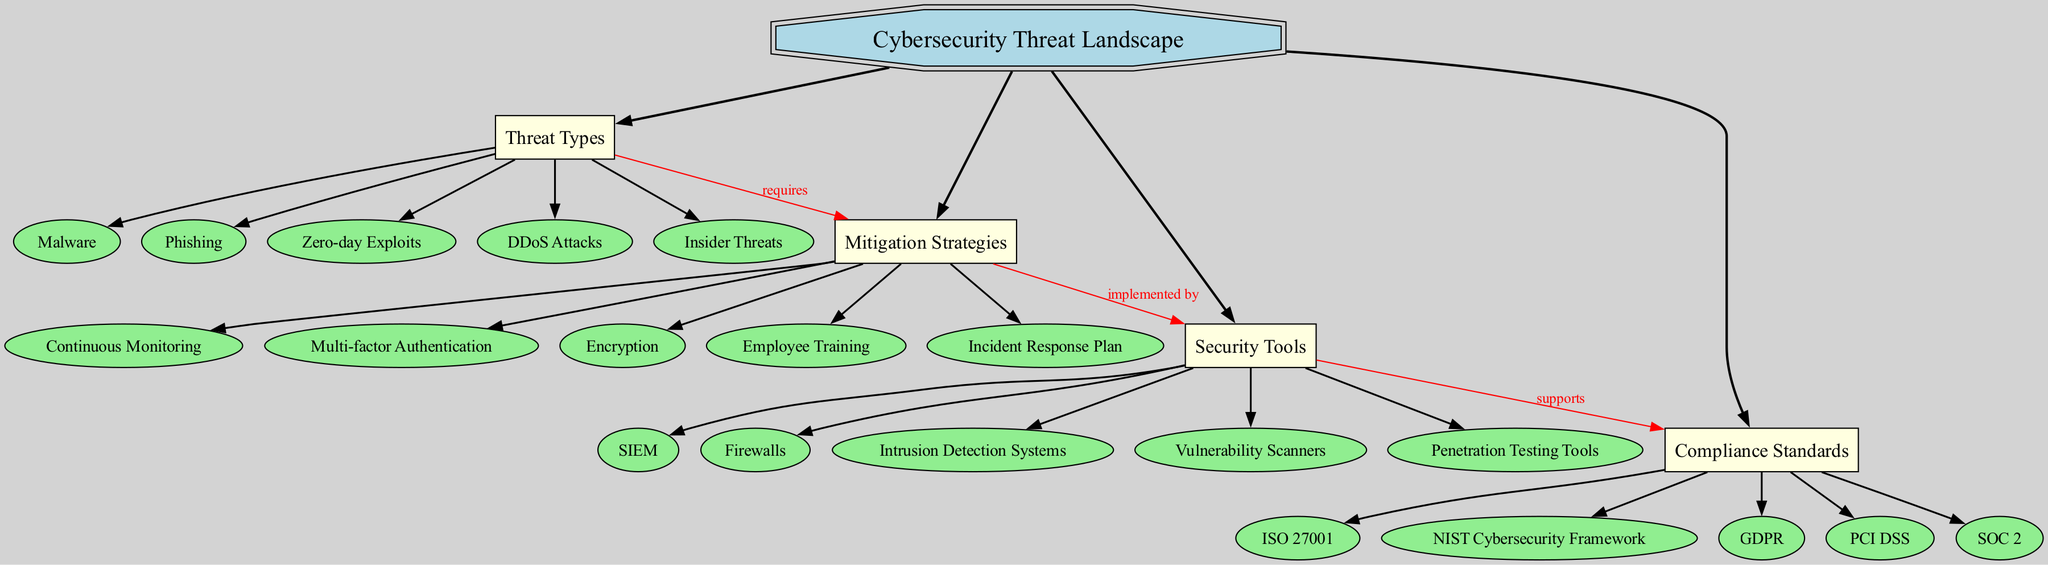What are the subnodes under Threat Types? The subnodes under "Threat Types" are listed directly connected to it in the diagram, which includes Malware, Phishing, Zero-day Exploits, DDoS Attacks, and Insider Threats.
Answer: Malware, Phishing, Zero-day Exploits, DDoS Attacks, Insider Threats How many main branches are there in the diagram? The diagram includes four main branches connected to the central concept "Cybersecurity Threat Landscape": Threat Types, Mitigation Strategies, Security Tools, and Compliance Standards. Counting these branches yields a total of four.
Answer: 4 What does Mitigation Strategies require? According to the connections in the diagram, Mitigation Strategies requires Threat Types, as indicated by the label "requires." This shows a direct relationship where understanding threat types informs mitigation strategies.
Answer: Threat Types Which Security Tool supports Compliance Standards? The diagram shows a connection labeled "supports" from Security Tools to Compliance Standards, meaning that the tools implemented will help meet the requirements of compliance standards. The specific tool isn't highlighted, but it's clear that there is a connection from one to the other.
Answer: Security Tools How many subnodes are in the Mitigation Strategies branch? The Mitigation Strategies branch lists five subnodes: Continuous Monitoring, Multi-factor Authentication, Encryption, Employee Training, and Incident Response Plan. Counting these gives a total of five subnodes under that branch.
Answer: 5 Which strategy is implemented by Security Tools? In the diagram, it shows that Mitigation Strategies are implemented by Security Tools. This indicates that various tools are necessary to carry out the strategies effectively in a cybersecurity context.
Answer: Mitigation Strategies How many connections are displayed in the diagram? The diagram presents three distinct connections that structure the relationships between the branches: Threat Types to Mitigation Strategies, Mitigation Strategies to Security Tools, and Security Tools to Compliance Standards. Counting them yields a total of three connections.
Answer: 3 What is the shape of the central concept node? The central concept node named "Cybersecurity Threat Landscape" is depicted as a double octagon, as represented in the diagram's design choice, indicating its significance and central role.
Answer: doubleoctagon What does the relationship between Threat Types and Mitigation Strategies indicate? The relationship indicates that understanding the Threat Types is essential for formulating appropriate Mitigation Strategies, as illustrated by the "requires" label between these two branches. This points toward a causal link in cybersecurity planning.
Answer: requires 